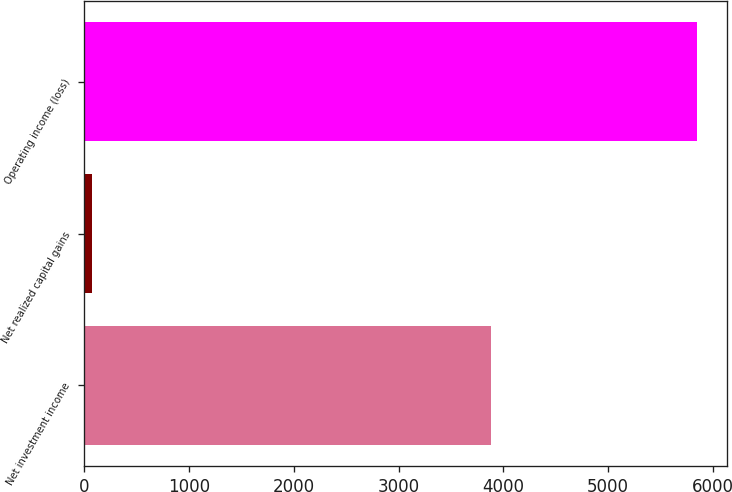Convert chart. <chart><loc_0><loc_0><loc_500><loc_500><bar_chart><fcel>Net investment income<fcel>Net realized capital gains<fcel>Operating income (loss)<nl><fcel>3879<fcel>75<fcel>5845<nl></chart> 